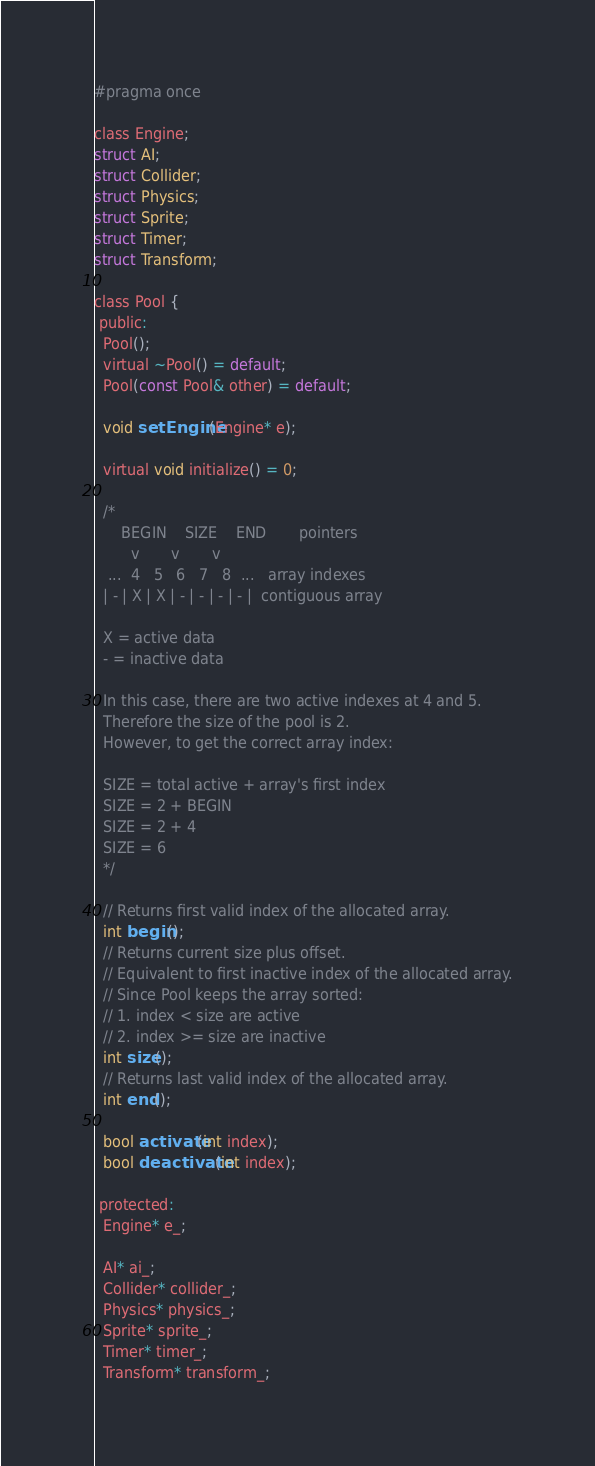Convert code to text. <code><loc_0><loc_0><loc_500><loc_500><_C_>#pragma once

class Engine;
struct AI;
struct Collider;
struct Physics;
struct Sprite;
struct Timer;
struct Transform;

class Pool {
 public:
  Pool();
  virtual ~Pool() = default;
  Pool(const Pool& other) = default;

  void setEngine(Engine* e);

  virtual void initialize() = 0;

  /*
      BEGIN    SIZE    END       pointers
        v       v       v
   ...  4   5   6   7   8  ...   array indexes
  | - | X | X | - | - | - | - |  contiguous array

  X = active data
  - = inactive data

  In this case, there are two active indexes at 4 and 5.
  Therefore the size of the pool is 2.
  However, to get the correct array index:

  SIZE = total active + array's first index
  SIZE = 2 + BEGIN
  SIZE = 2 + 4
  SIZE = 6
  */

  // Returns first valid index of the allocated array.
  int begin();
  // Returns current size plus offset.
  // Equivalent to first inactive index of the allocated array.
  // Since Pool keeps the array sorted:
  // 1. index < size are active
  // 2. index >= size are inactive
  int size();
  // Returns last valid index of the allocated array.
  int end();

  bool activate(int index);
  bool deactivate(int index);

 protected:
  Engine* e_;

  AI* ai_;
  Collider* collider_;
  Physics* physics_;
  Sprite* sprite_;
  Timer* timer_;
  Transform* transform_;
</code> 